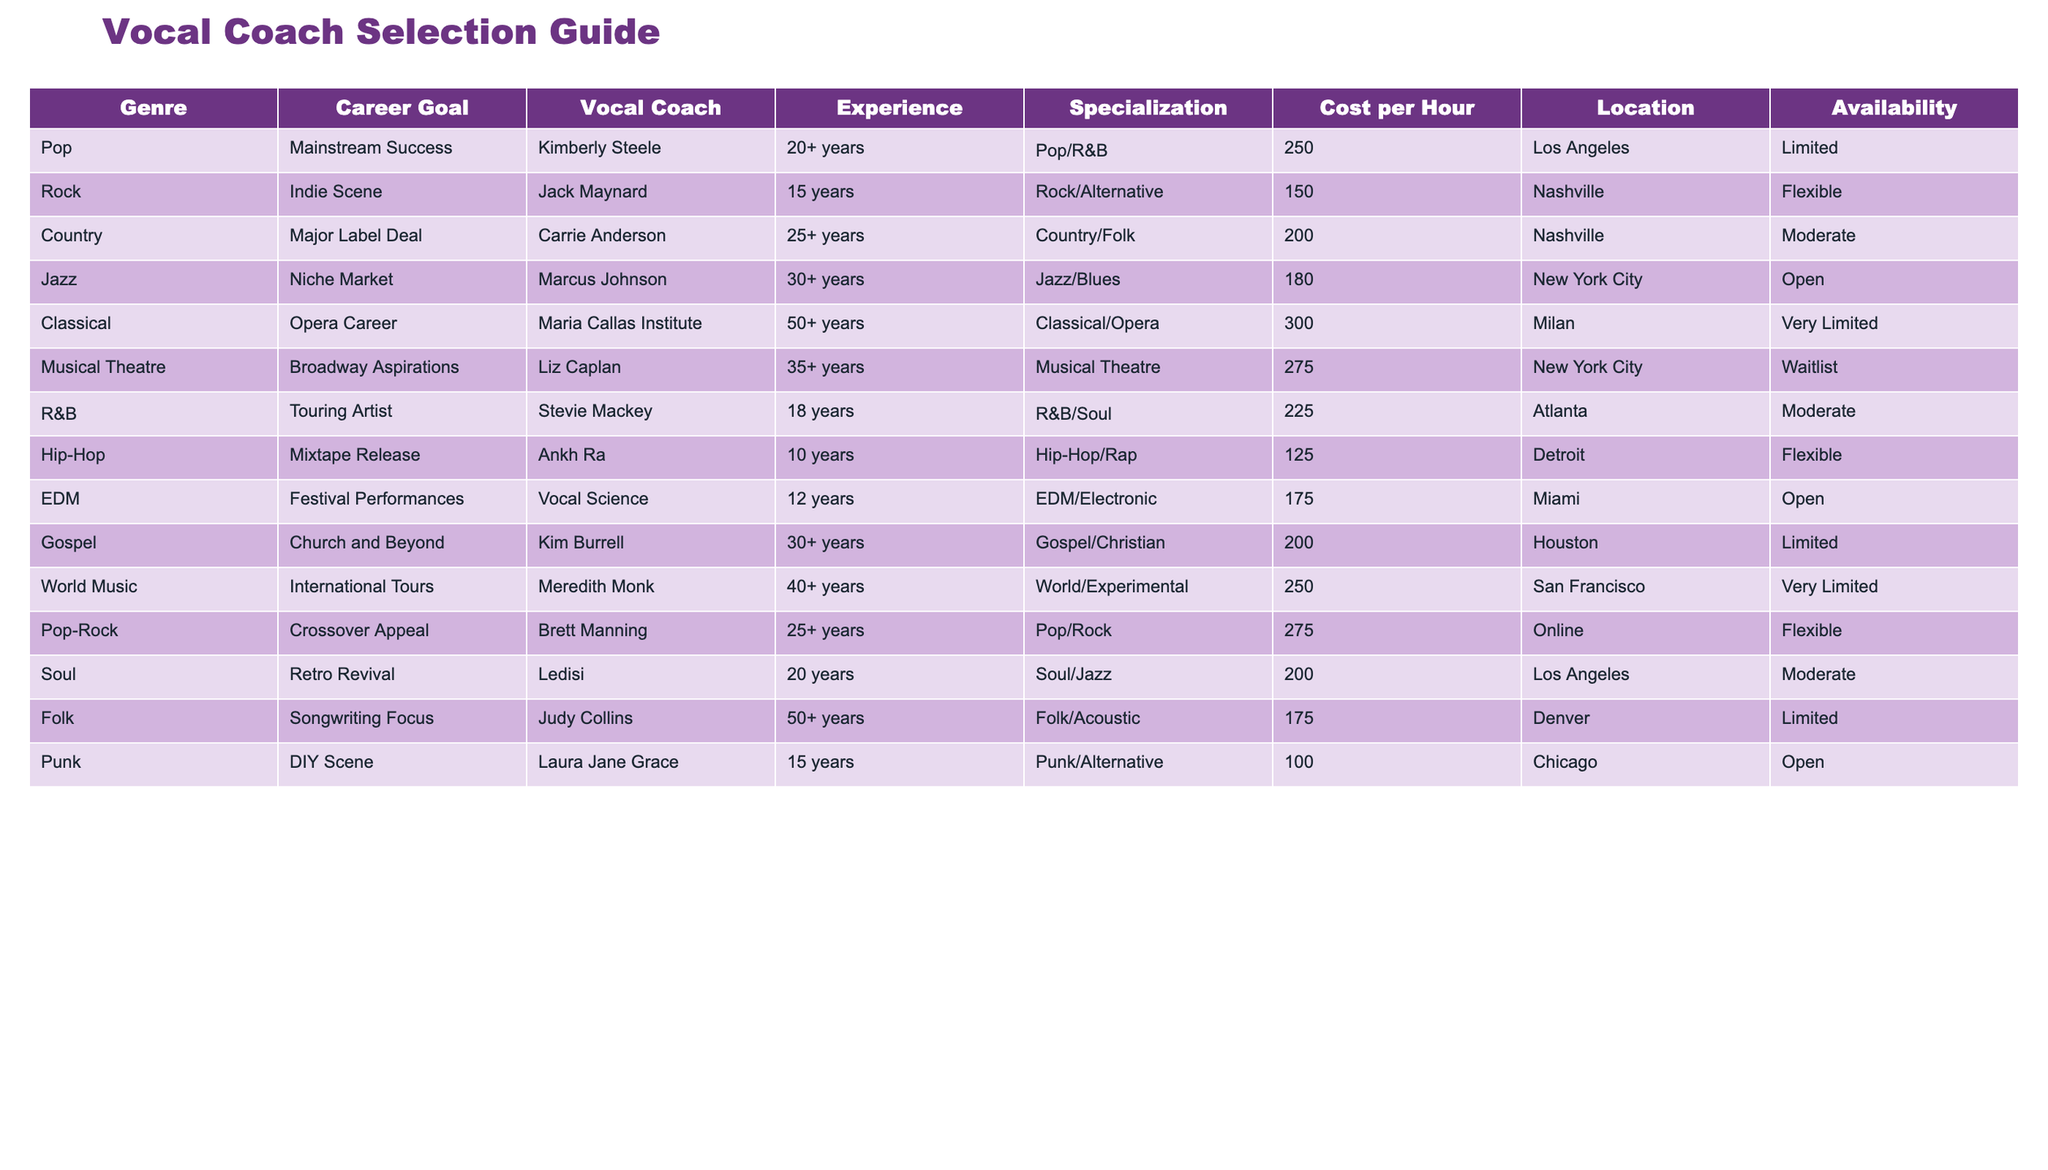What is the cost per hour of the vocal coach for R&B genre? The table lists Stevie Mackey as the vocal coach for the R&B genre, and his cost per hour is directly stated as 225.
Answer: 225 Which vocal coach has the most experience? The table shows that the Maria Callas Institute has the most experience listed at 50+ years, specifically in the Classical/Opera specialization.
Answer: 50+ years Is Carrie Anderson available for coaching? According to the table, Carrie Anderson's availability is noted as "Moderate," which implies that she is available, but not at all times.
Answer: Yes How much does a vocal coach specializing in Punk charge per hour? The table shows that Laura Jane Grace is the vocal coach specializing in Punk, and her cost per hour is listed as 100.
Answer: 100 Which city does the vocal coach with specialization in Jazz operate in, and what is their hourly rate? The table indicates that Marcus Johnson operates in New York City with an hourly rate of 180 for his specialization in Jazz/Blues.
Answer: New York City, 180 What is the average cost per hour of vocal coaches specializing in genres other than Classical? First, we need to sum the costs of all other genres: (250 + 150 + 200 + 180 + 275 + 225 + 125 + 175 + 200 + 250 + 275 + 200 + 175 + 100) = 2,705. There are 14 data points, so the average cost is 2,705/14 ≈ 193.21.
Answer: 193.21 Are there any vocal coaches listed with very limited availability? The data shows that both the Maria Callas Institute and Meredith Monk have "Very Limited" availability according to the table.
Answer: Yes How much more expensive is a vocal coach specializing in Musical Theatre compared to one in Hip-Hop? The cost for Liz Caplan in Musical Theatre is 275, and for Ankh Ra in Hip-Hop, it is 125. The difference is thus calculated as 275 - 125 = 150.
Answer: 150 Which genre has the least expensive coaching option? Upon reviewing the table, the least expensive coaching option is provided by Laura Jane Grace in the Punk genre, costing 100 per hour.
Answer: Punk, 100 